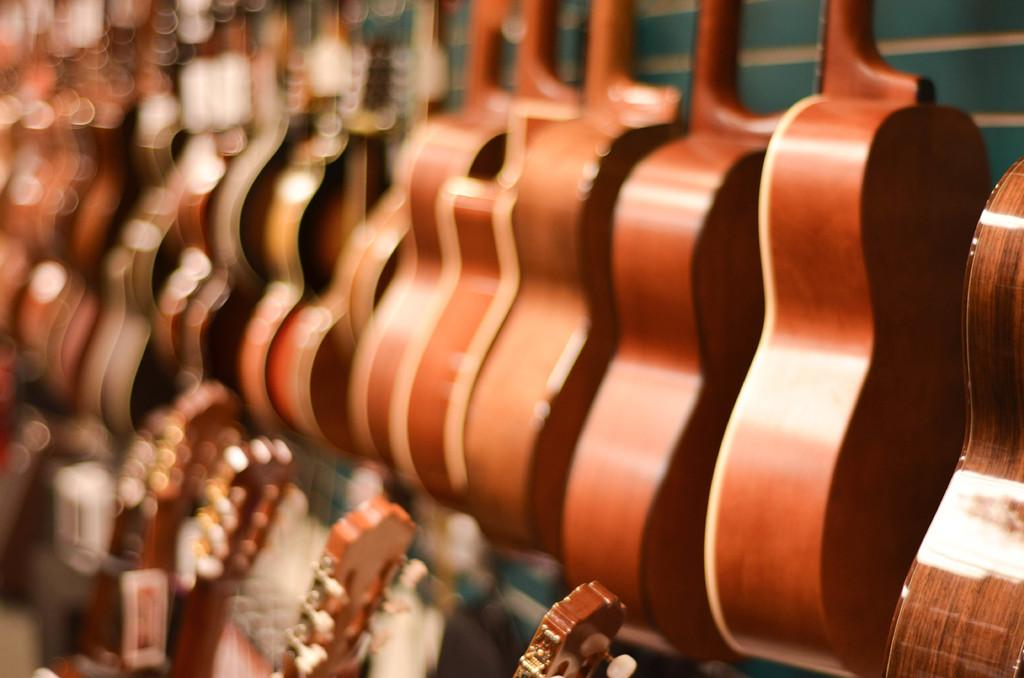What type of musical instruments are present in the image? There are multiple guitars in the image. Can you describe the number of guitars in the image? The number of guitars is not specified, but there are multiple guitars present. What might the guitars be used for in the image? The guitars might be used for playing music or as a decorative element. How many girls are playing the guitars in the image? There is no mention of girls or anyone playing the guitars in the image. What type of fish can be seen swimming around the guitars in the image? There are no fish present in the image; it only features guitars. 